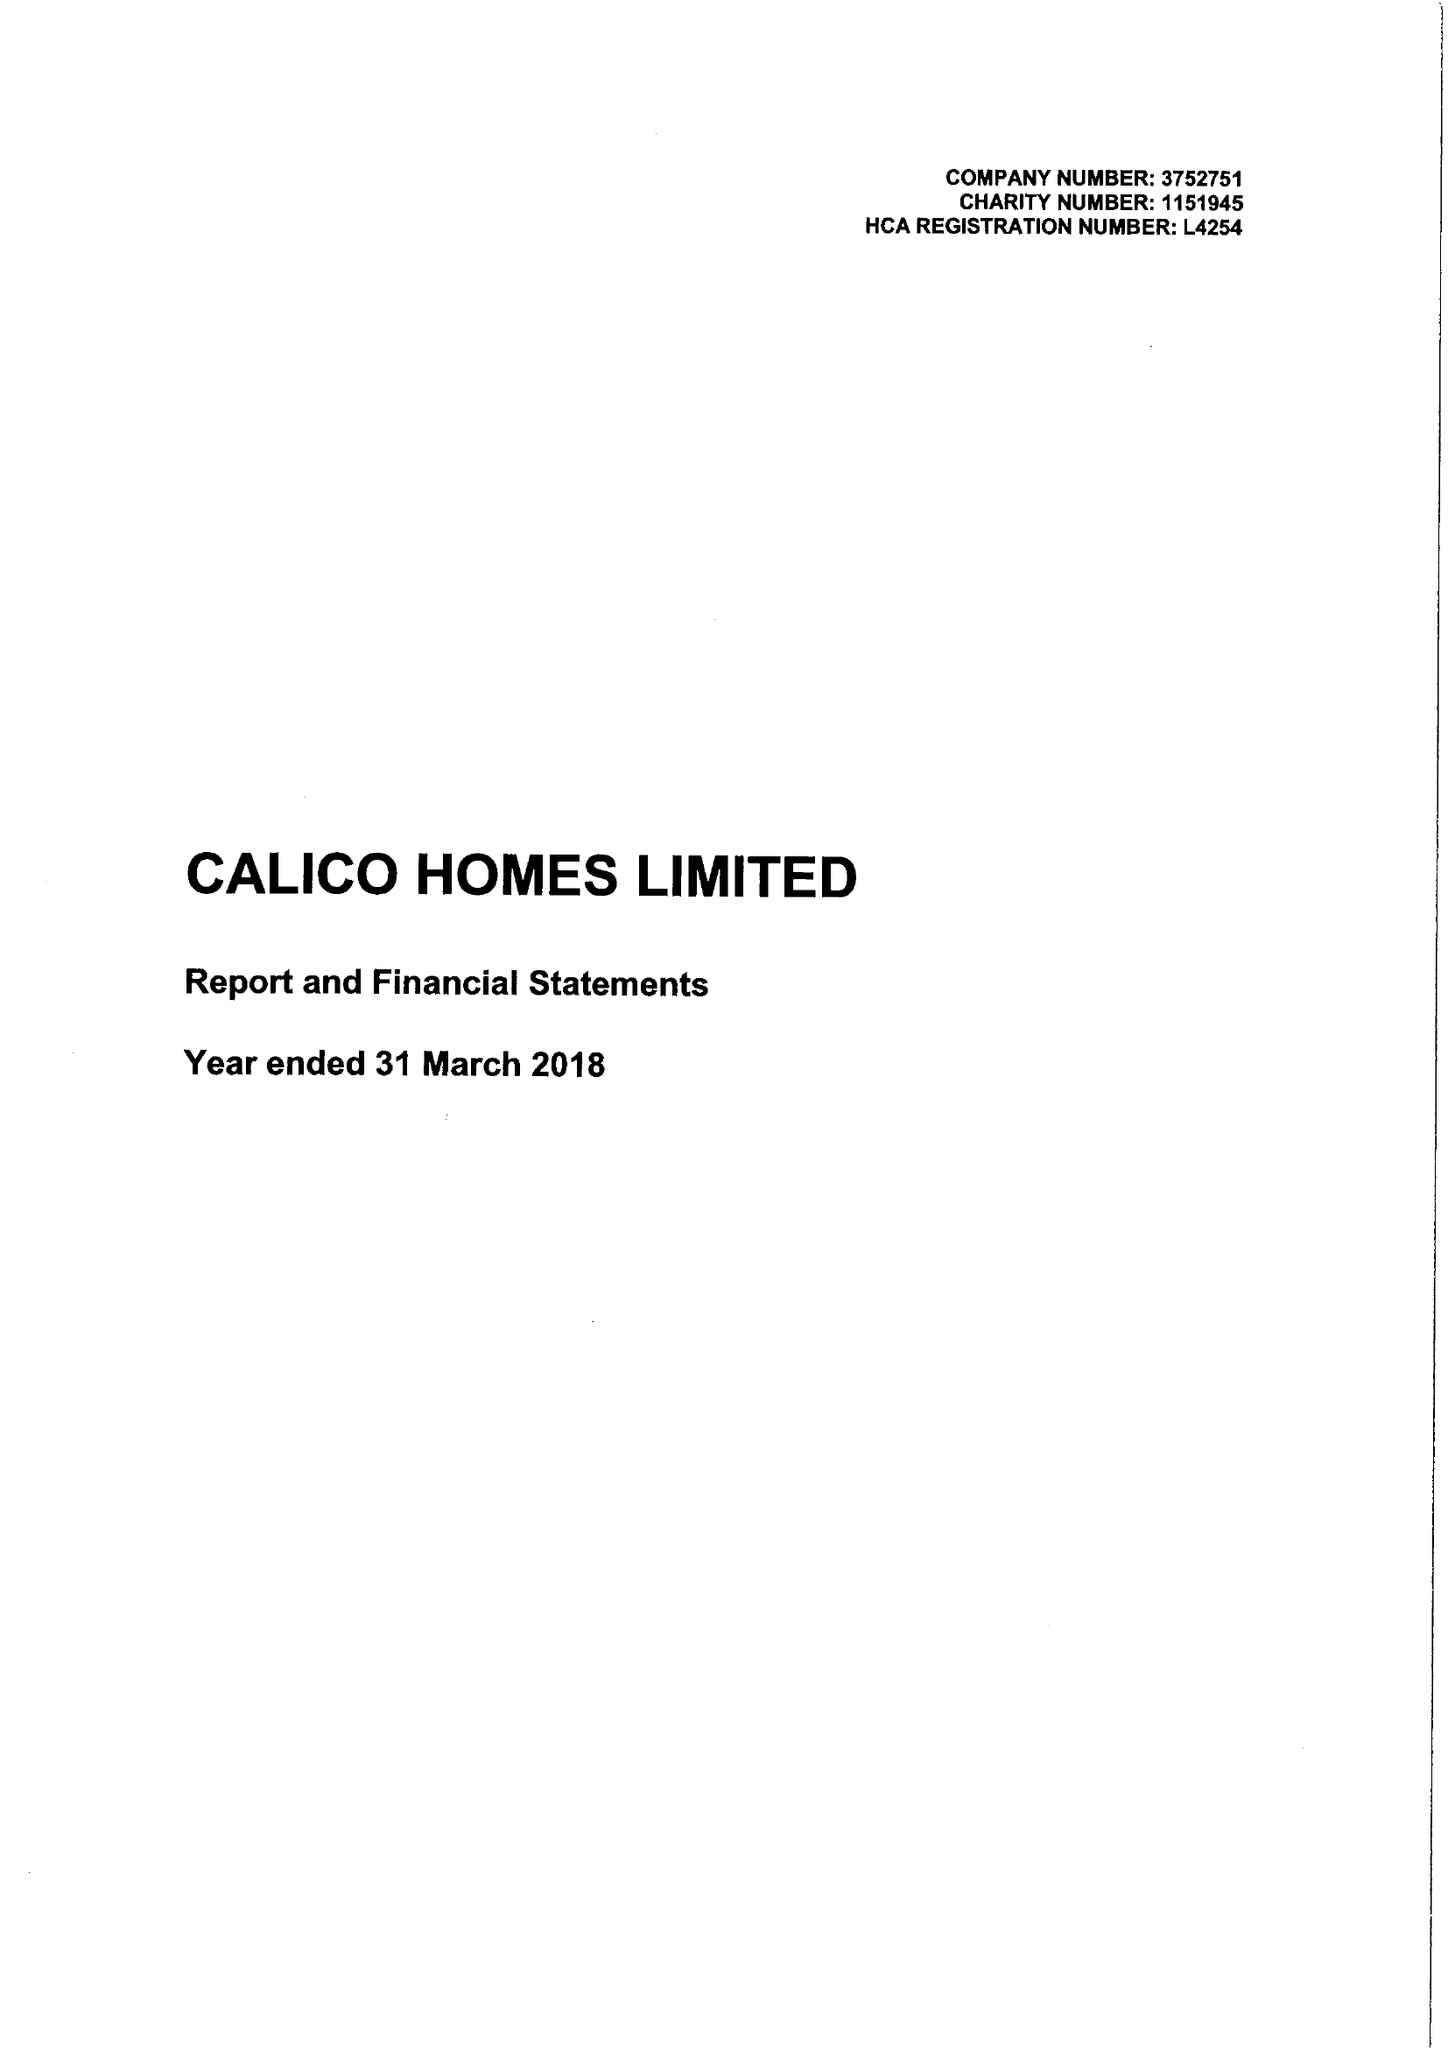What is the value for the charity_number?
Answer the question using a single word or phrase. 1151945 